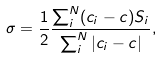<formula> <loc_0><loc_0><loc_500><loc_500>\sigma = \frac { 1 } { 2 } \frac { \sum _ { i } ^ { N } ( c _ { i } - c ) S _ { i } } { \sum _ { i } ^ { N } | c _ { i } - c | } ,</formula> 